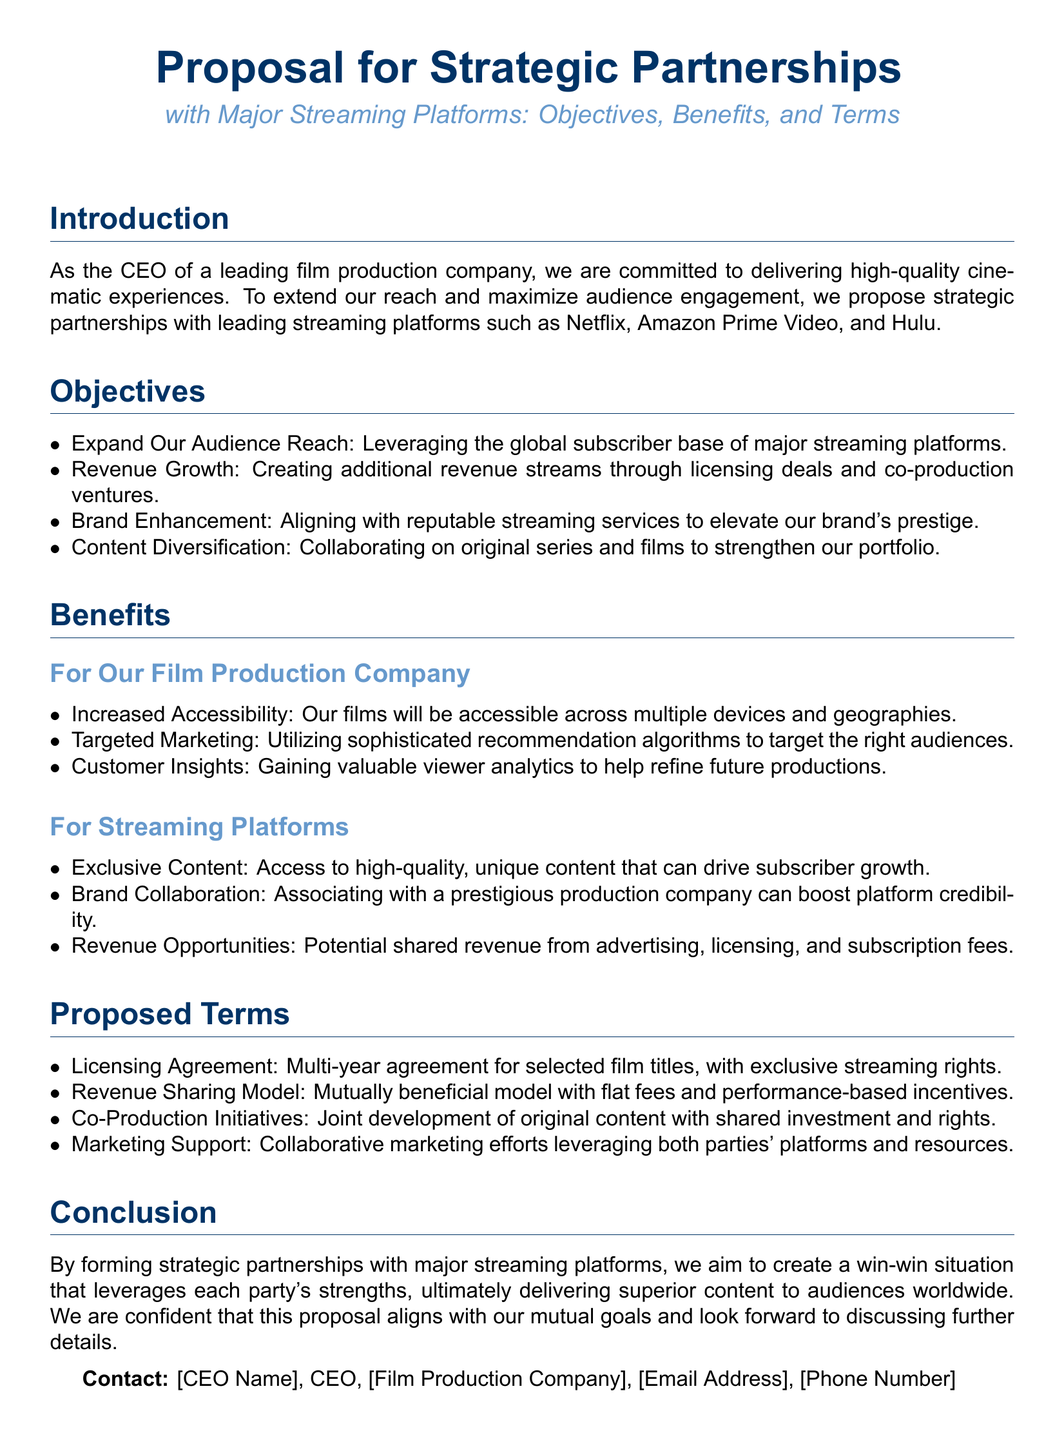What are the names of the major streaming platforms mentioned? The document lists Netflix, Amazon Prime Video, and Hulu as the major streaming platforms for proposed partnerships.
Answer: Netflix, Amazon Prime Video, Hulu What is one objective of the strategic partnerships? The document states that one objective is to leverage the global subscriber base of major streaming platforms to expand audience reach.
Answer: Expand Audience Reach What type of agreement is proposed for selected film titles? The document specifies a multi-year licensing agreement with exclusive streaming rights for selected film titles.
Answer: Licensing Agreement What is mentioned as a benefit for streaming platforms? One benefit stated in the document for streaming platforms is access to high-quality, unique content that can drive subscriber growth.
Answer: Exclusive Content What model is suggested for revenue sharing? The document outlines a mutually beneficial revenue-sharing model with flat fees and performance-based incentives.
Answer: Revenue Sharing Model What will be gained through customer insights? The document indicates that valuable viewer analytics will help refine future productions.
Answer: Valuable viewer analytics What is one proposed collaboration aspect mentioned in the terms? The document includes joint development of original content with shared investment and rights as a proposed collaboration aspect.
Answer: Co-Production Initiatives What type of marketing support is suggested? The document suggests collaborative marketing efforts that leverage both parties' platforms and resources as marketing support.
Answer: Collaborative marketing efforts What is the contact information for the CEO? The document provides the contact details for the CEO, including name, email address, and phone number (placeholders in this case).
Answer: [CEO Name], [Email Address], [Phone Number] What is the primary focus of the proposal? The document focuses on forming strategic partnerships with major streaming platforms to enhance content delivery and expand engagement.
Answer: Strategic partnerships with major streaming platforms 